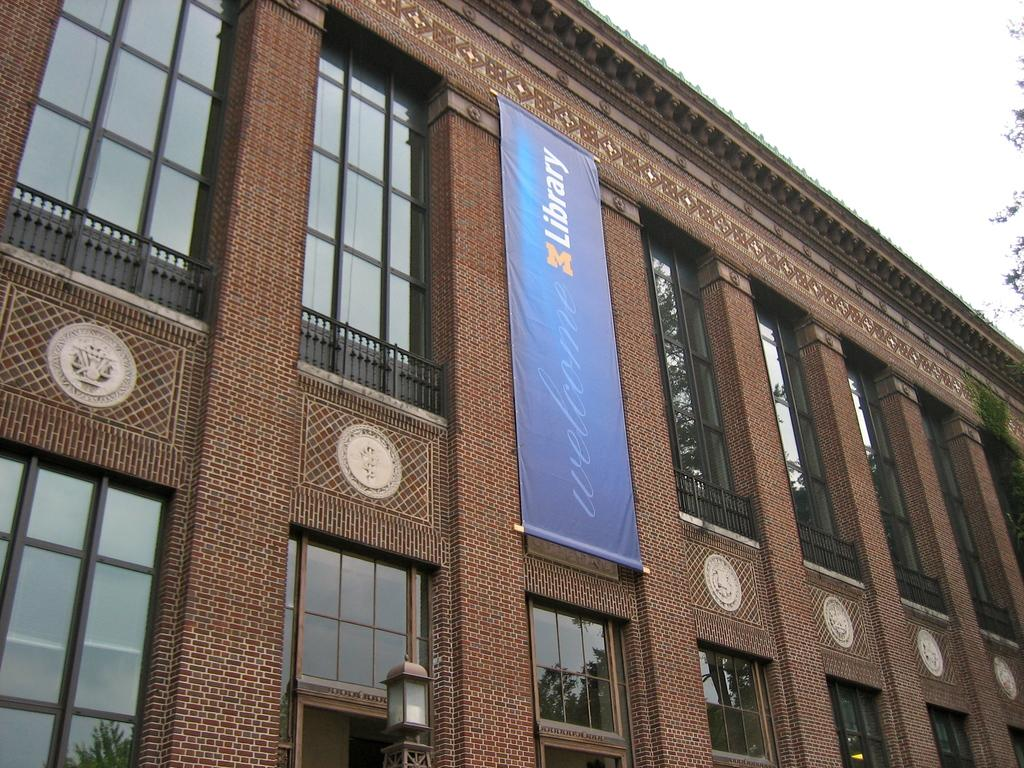<image>
Provide a brief description of the given image. A large brick library with a blue banner that says Welcome on it. 